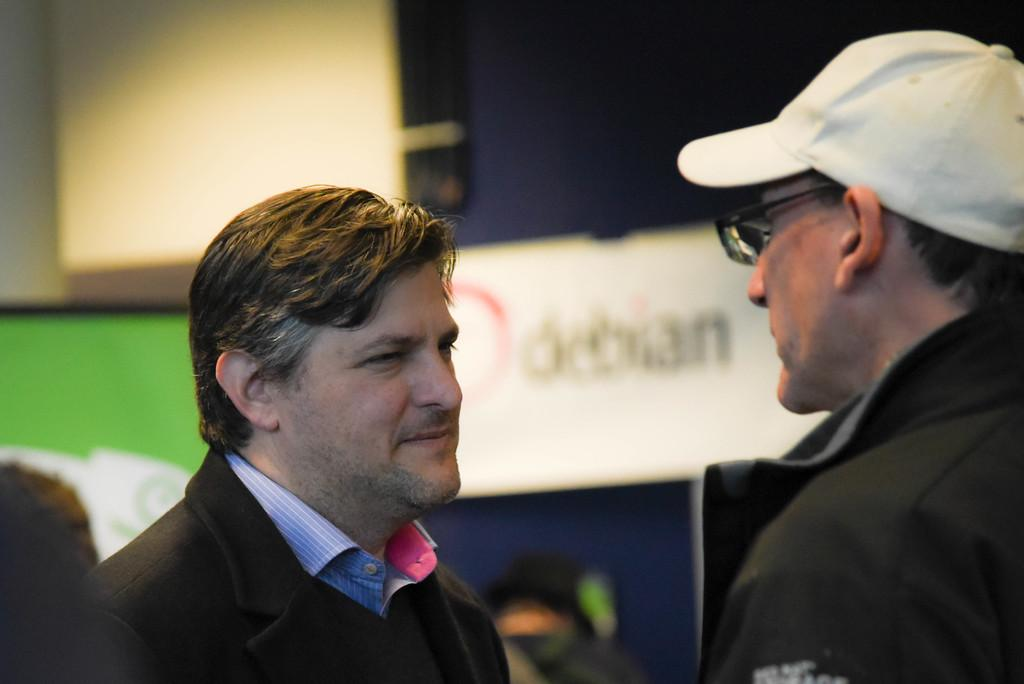How many people are in the image? There are two people in the image. What colors are the dresses worn by the people? One person is wearing a black dress, and the other person is wearing a blue dress. Can you describe the accessories worn by one of the people? One person is wearing specs and a cap. What can be seen in the background of the image, although it is blurry? There are boards visible in the background. What type of chin is visible on the person wearing the blue dress? There is no chin visible on the person wearing the blue dress; the image only shows the person's upper body. 